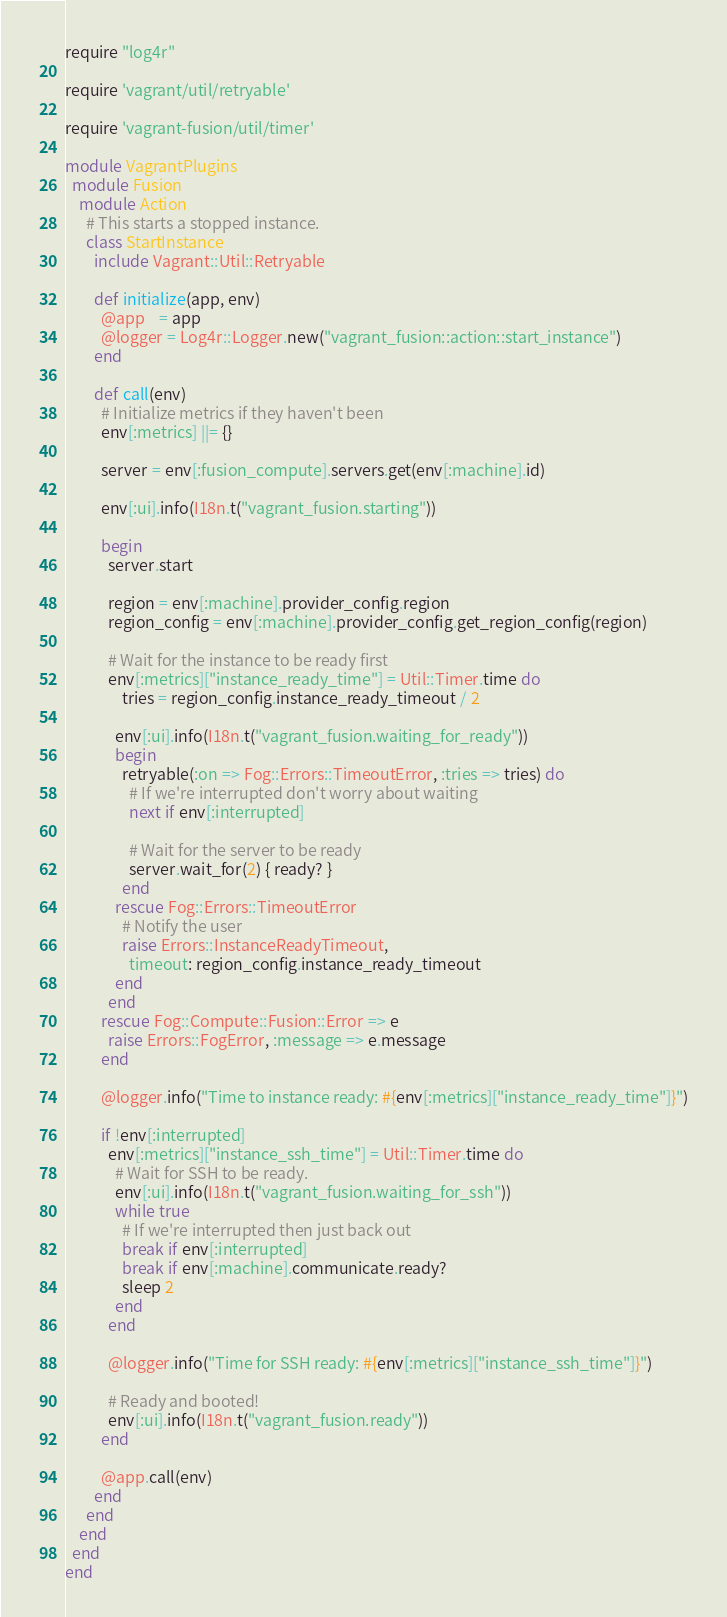Convert code to text. <code><loc_0><loc_0><loc_500><loc_500><_Ruby_>require "log4r"

require 'vagrant/util/retryable'

require 'vagrant-fusion/util/timer'

module VagrantPlugins
  module Fusion
    module Action
      # This starts a stopped instance.
      class StartInstance
        include Vagrant::Util::Retryable

        def initialize(app, env)
          @app    = app
          @logger = Log4r::Logger.new("vagrant_fusion::action::start_instance")
        end

        def call(env)
          # Initialize metrics if they haven't been
          env[:metrics] ||= {}

          server = env[:fusion_compute].servers.get(env[:machine].id)

          env[:ui].info(I18n.t("vagrant_fusion.starting"))

          begin
            server.start

            region = env[:machine].provider_config.region
            region_config = env[:machine].provider_config.get_region_config(region)

            # Wait for the instance to be ready first
            env[:metrics]["instance_ready_time"] = Util::Timer.time do
                tries = region_config.instance_ready_timeout / 2

              env[:ui].info(I18n.t("vagrant_fusion.waiting_for_ready"))
              begin
                retryable(:on => Fog::Errors::TimeoutError, :tries => tries) do
                  # If we're interrupted don't worry about waiting
                  next if env[:interrupted]

                  # Wait for the server to be ready
                  server.wait_for(2) { ready? }
                end
              rescue Fog::Errors::TimeoutError
                # Notify the user
                raise Errors::InstanceReadyTimeout,
                  timeout: region_config.instance_ready_timeout
              end
            end
          rescue Fog::Compute::Fusion::Error => e
            raise Errors::FogError, :message => e.message
          end

          @logger.info("Time to instance ready: #{env[:metrics]["instance_ready_time"]}")

          if !env[:interrupted]
            env[:metrics]["instance_ssh_time"] = Util::Timer.time do
              # Wait for SSH to be ready.
              env[:ui].info(I18n.t("vagrant_fusion.waiting_for_ssh"))
              while true
                # If we're interrupted then just back out
                break if env[:interrupted]
                break if env[:machine].communicate.ready?
                sleep 2
              end
            end

            @logger.info("Time for SSH ready: #{env[:metrics]["instance_ssh_time"]}")

            # Ready and booted!
            env[:ui].info(I18n.t("vagrant_fusion.ready"))
          end

          @app.call(env)
        end
      end
    end
  end
end
</code> 